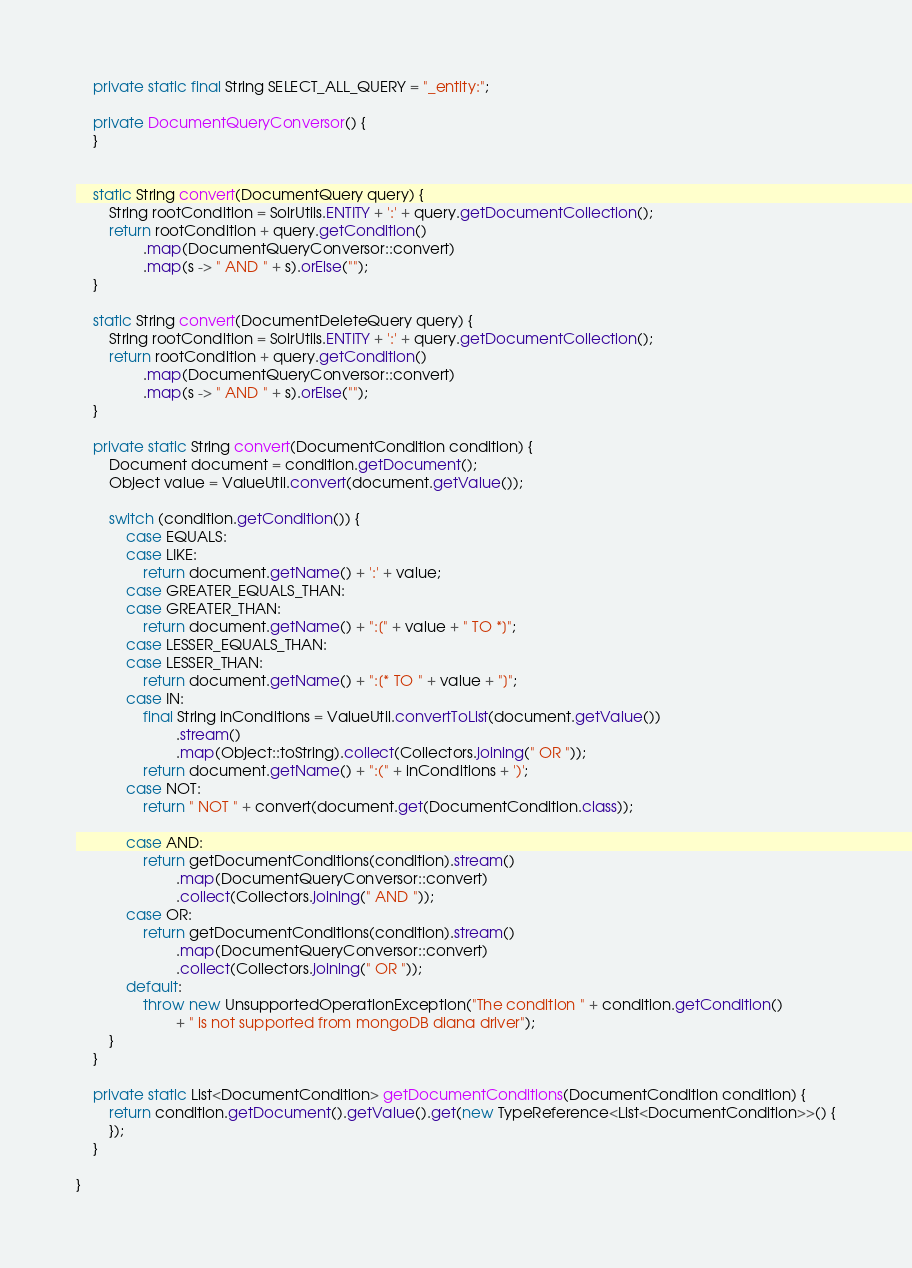Convert code to text. <code><loc_0><loc_0><loc_500><loc_500><_Java_>    private static final String SELECT_ALL_QUERY = "_entity:";

    private DocumentQueryConversor() {
    }


    static String convert(DocumentQuery query) {
        String rootCondition = SolrUtils.ENTITY + ':' + query.getDocumentCollection();
        return rootCondition + query.getCondition()
                .map(DocumentQueryConversor::convert)
                .map(s -> " AND " + s).orElse("");
    }

    static String convert(DocumentDeleteQuery query) {
        String rootCondition = SolrUtils.ENTITY + ':' + query.getDocumentCollection();
        return rootCondition + query.getCondition()
                .map(DocumentQueryConversor::convert)
                .map(s -> " AND " + s).orElse("");
    }

    private static String convert(DocumentCondition condition) {
        Document document = condition.getDocument();
        Object value = ValueUtil.convert(document.getValue());

        switch (condition.getCondition()) {
            case EQUALS:
            case LIKE:
                return document.getName() + ':' + value;
            case GREATER_EQUALS_THAN:
            case GREATER_THAN:
                return document.getName() + ":[" + value + " TO *]";
            case LESSER_EQUALS_THAN:
            case LESSER_THAN:
                return document.getName() + ":[* TO " + value + "]";
            case IN:
                final String inConditions = ValueUtil.convertToList(document.getValue())
                        .stream()
                        .map(Object::toString).collect(Collectors.joining(" OR "));
                return document.getName() + ":(" + inConditions + ')';
            case NOT:
                return " NOT " + convert(document.get(DocumentCondition.class));

            case AND:
                return getDocumentConditions(condition).stream()
                        .map(DocumentQueryConversor::convert)
                        .collect(Collectors.joining(" AND "));
            case OR:
                return getDocumentConditions(condition).stream()
                        .map(DocumentQueryConversor::convert)
                        .collect(Collectors.joining(" OR "));
            default:
                throw new UnsupportedOperationException("The condition " + condition.getCondition()
                        + " is not supported from mongoDB diana driver");
        }
    }

    private static List<DocumentCondition> getDocumentConditions(DocumentCondition condition) {
        return condition.getDocument().getValue().get(new TypeReference<List<DocumentCondition>>() {
        });
    }

}
</code> 